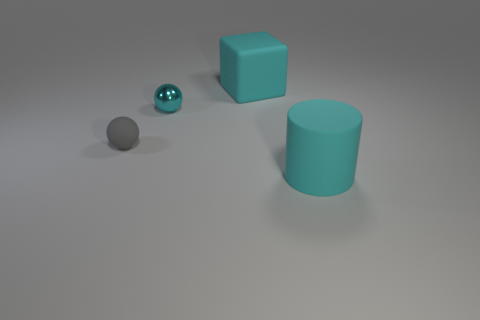The thing that is to the left of the cyan rubber cylinder and in front of the tiny metal object is made of what material?
Offer a very short reply. Rubber. Is the color of the shiny object the same as the tiny sphere left of the shiny ball?
Provide a short and direct response. No. What material is the gray sphere that is the same size as the cyan ball?
Offer a terse response. Rubber. Are there any other small gray balls that have the same material as the gray ball?
Offer a very short reply. No. How many tiny objects are there?
Your answer should be compact. 2. Does the cylinder have the same material as the cyan object left of the big cyan matte cube?
Offer a terse response. No. There is a tiny object that is the same color as the cylinder; what material is it?
Your response must be concise. Metal. How many large matte things are the same color as the small rubber ball?
Provide a succinct answer. 0. What size is the gray object?
Provide a short and direct response. Small. Does the small cyan object have the same shape as the object behind the cyan metallic sphere?
Your response must be concise. No. 